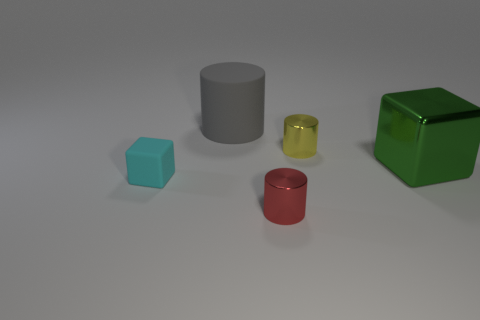Add 1 big green cylinders. How many objects exist? 6 Subtract all cylinders. How many objects are left? 2 Add 4 large gray shiny cubes. How many large gray shiny cubes exist? 4 Subtract 0 purple cubes. How many objects are left? 5 Subtract all small cylinders. Subtract all red metal cylinders. How many objects are left? 2 Add 1 green metal things. How many green metal things are left? 2 